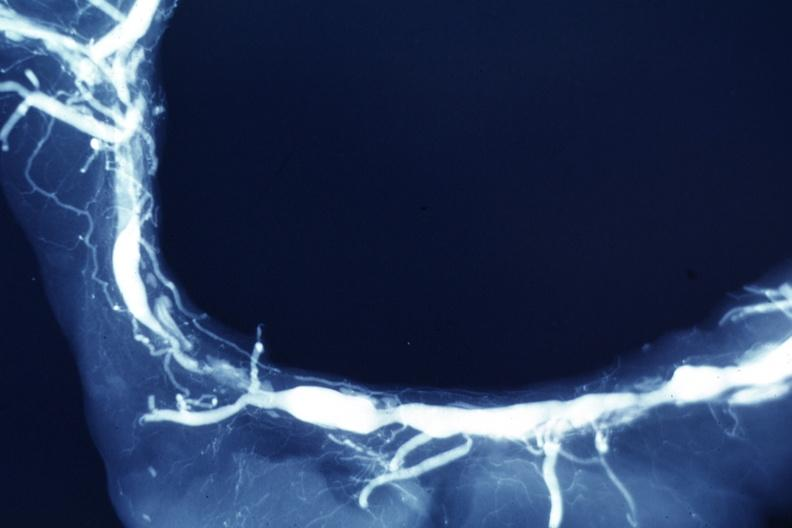s amyloidosis present?
Answer the question using a single word or phrase. No 